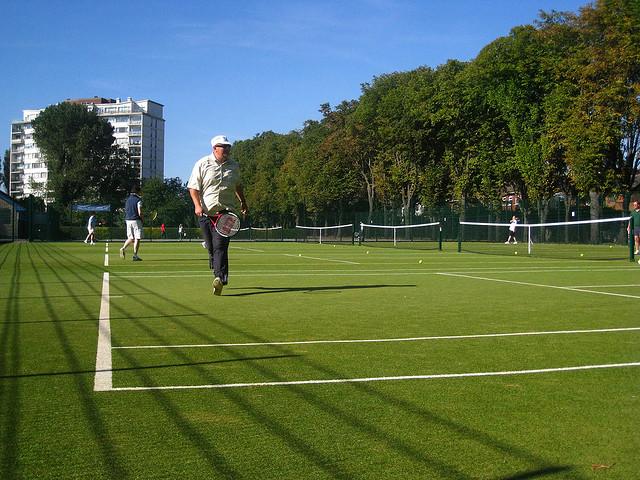Is the man wearing tennis clothes?
Short answer required. No. What type of court type are these people playing tennis on?
Quick response, please. Grass. What sport are these people playing?
Quick response, please. Tennis. 